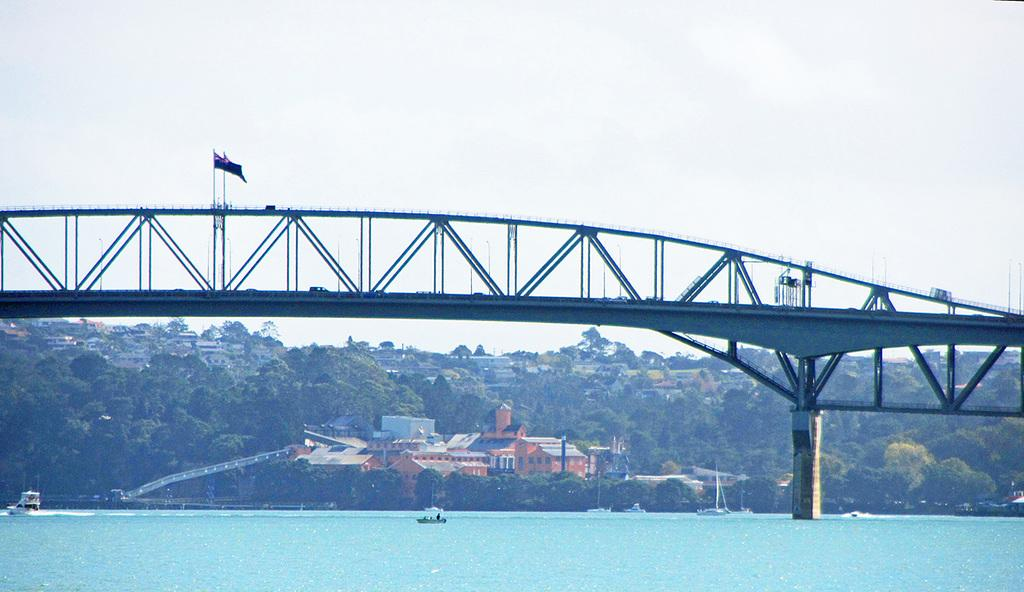What is located at the bottom of the image? There is a boat in the water at the bottom of the image. What can be seen in the middle of the image? There are buildings in the middle of the image. What type of structure is present in the image? There is a very big bridge in the image. What is the condition of the sky in the image? The sky is cloudy at the top of the image. What time of day is it in the image, as indicated by the hour on the clock tower? There is no clock tower present in the image, so it is not possible to determine the hour. What type of gardening tool is being used by the person in the boat? There is no person or gardening tool visible in the boat in the image. 